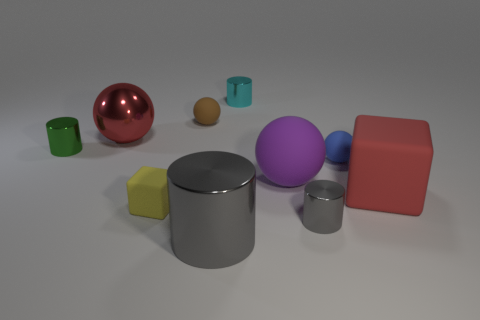Are there the same number of red rubber cubes that are to the right of the large red cube and big brown cylinders?
Provide a short and direct response. Yes. What number of metal things are both to the right of the yellow object and in front of the small cyan metallic cylinder?
Offer a very short reply. 2. Does the matte thing that is behind the green thing have the same shape as the tiny gray thing?
Offer a terse response. No. There is a blue sphere that is the same size as the cyan metal object; what is its material?
Offer a terse response. Rubber. Is the number of small metallic cylinders right of the brown matte thing the same as the number of small gray metallic cylinders that are to the left of the small gray cylinder?
Give a very brief answer. No. What number of red metallic spheres are to the left of the red object to the left of the blue ball that is to the right of the big cylinder?
Provide a succinct answer. 0. There is a tiny matte block; does it have the same color as the rubber cube that is on the right side of the yellow matte thing?
Your answer should be compact. No. What size is the cyan object that is made of the same material as the large cylinder?
Keep it short and to the point. Small. Are there more gray metallic cylinders that are behind the brown thing than brown objects?
Offer a terse response. No. The red object that is on the right side of the big shiny thing that is in front of the big rubber thing that is on the left side of the tiny gray thing is made of what material?
Your answer should be very brief. Rubber. 